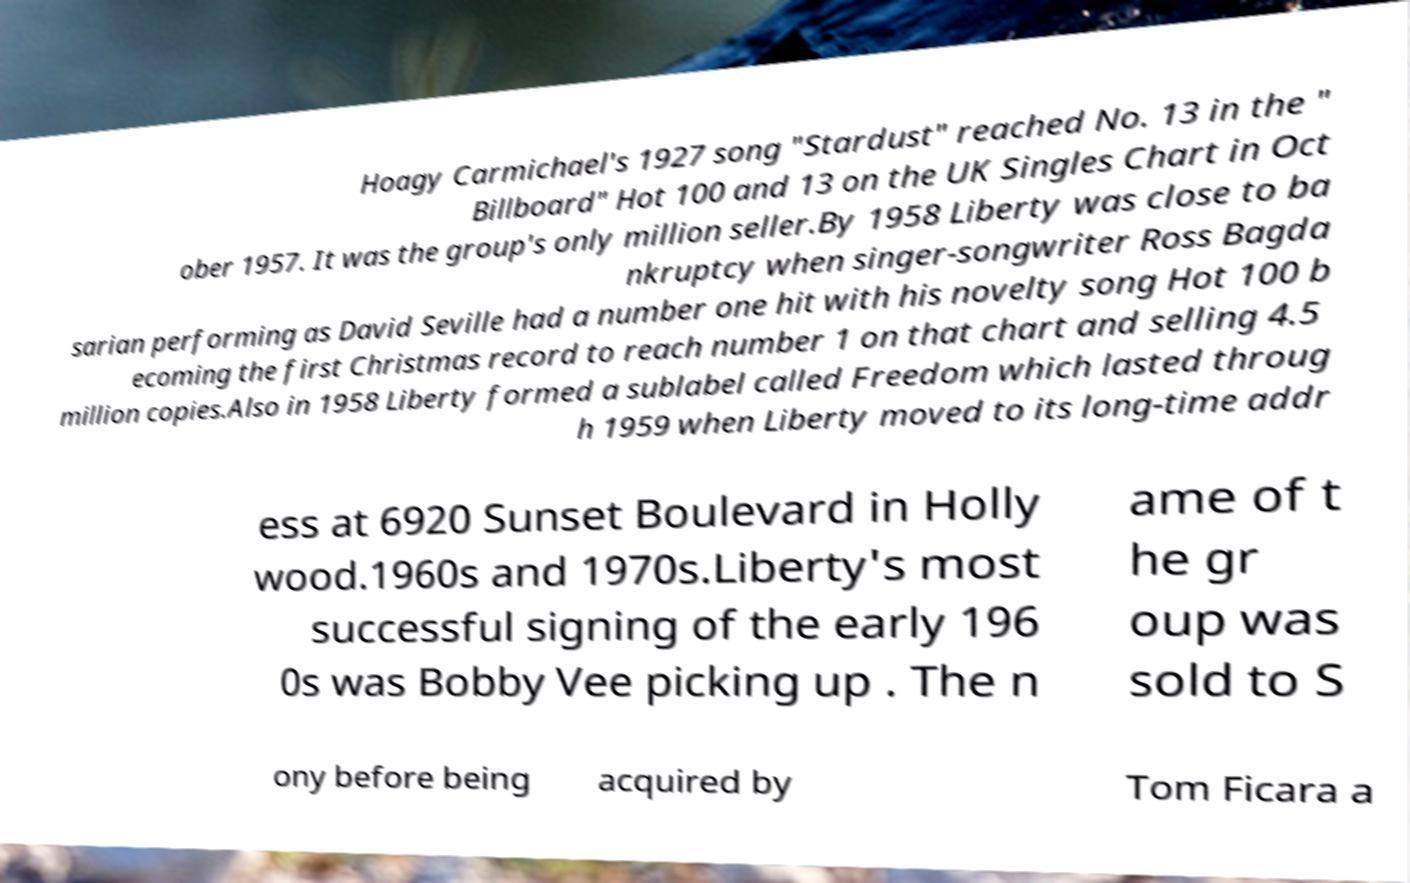What messages or text are displayed in this image? I need them in a readable, typed format. Hoagy Carmichael's 1927 song "Stardust" reached No. 13 in the " Billboard" Hot 100 and 13 on the UK Singles Chart in Oct ober 1957. It was the group's only million seller.By 1958 Liberty was close to ba nkruptcy when singer-songwriter Ross Bagda sarian performing as David Seville had a number one hit with his novelty song Hot 100 b ecoming the first Christmas record to reach number 1 on that chart and selling 4.5 million copies.Also in 1958 Liberty formed a sublabel called Freedom which lasted throug h 1959 when Liberty moved to its long-time addr ess at 6920 Sunset Boulevard in Holly wood.1960s and 1970s.Liberty's most successful signing of the early 196 0s was Bobby Vee picking up . The n ame of t he gr oup was sold to S ony before being acquired by Tom Ficara a 